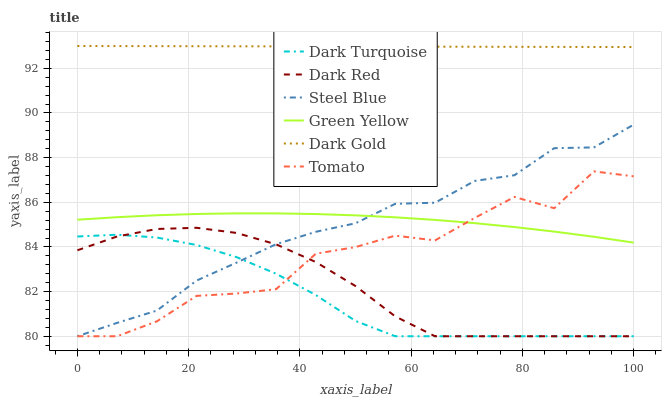Does Dark Turquoise have the minimum area under the curve?
Answer yes or no. Yes. Does Dark Gold have the maximum area under the curve?
Answer yes or no. Yes. Does Dark Gold have the minimum area under the curve?
Answer yes or no. No. Does Dark Turquoise have the maximum area under the curve?
Answer yes or no. No. Is Dark Gold the smoothest?
Answer yes or no. Yes. Is Tomato the roughest?
Answer yes or no. Yes. Is Dark Turquoise the smoothest?
Answer yes or no. No. Is Dark Turquoise the roughest?
Answer yes or no. No. Does Tomato have the lowest value?
Answer yes or no. Yes. Does Dark Gold have the lowest value?
Answer yes or no. No. Does Dark Gold have the highest value?
Answer yes or no. Yes. Does Dark Turquoise have the highest value?
Answer yes or no. No. Is Dark Red less than Dark Gold?
Answer yes or no. Yes. Is Green Yellow greater than Dark Red?
Answer yes or no. Yes. Does Tomato intersect Dark Red?
Answer yes or no. Yes. Is Tomato less than Dark Red?
Answer yes or no. No. Is Tomato greater than Dark Red?
Answer yes or no. No. Does Dark Red intersect Dark Gold?
Answer yes or no. No. 